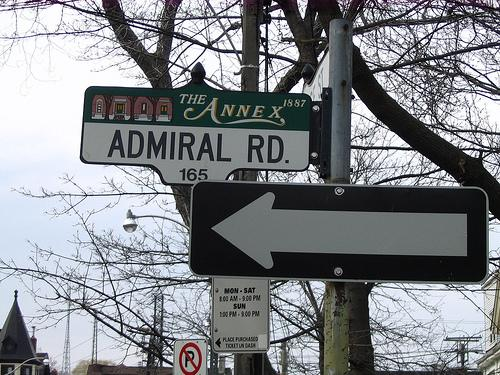List the most prominent elements seen in the image. Large white arrow, street sign, no parking sign, light post, tree branches, telephone cables Provide a brief overview of the dominant objects in the image. The image features a large white arrow on a black sign, several street signs, a no parking sign, a light post with a street lamp, and a background of trees and telephone cables. Write a short description of the street fixtures that the image captures. The image showcases a large white arrow sign, street signs, a no parking sign, and a light post amid a setting of tree branches and telephone cables. Describe the overall scene of the image in a single sentence. The image displays a street scene with various signs, a light post, and tree branches and telephone cables in the background. Describe the image focusing on the main objects and their overall appearance. The image exhibits several street signs, including a prominent large white arrow on a black background, accompanied by a no parking sign and a light post, set against a backdrop of tree branches and telephone cables. Describe the objects displayed in the foreground of the picture. In the foreground, there is a large white arrow on a black sign, a green and white street sign, a no parking sign, and a light post with a street lamp. Explain the arrangement of prominent signage and objects within the image. The image has a large white arrow on a black sign near the center, surrounded by various street signs and a no parking sign, with a light post nearby and tree branches and telephone cables in the background. Give a concise summary of what appears to be happening in the image. The image captures a street scene with various signs, a light post, and trees and telephone cables in the backdrop. Using poetic language, describe the main elements within the image. Amidst a symphony of street signs, a bold white arrow adorns a black canvas, with a no parking decree beneath and a sentinel light post nearby, while tree branches and melodies of telephone cables linger in the distance. 